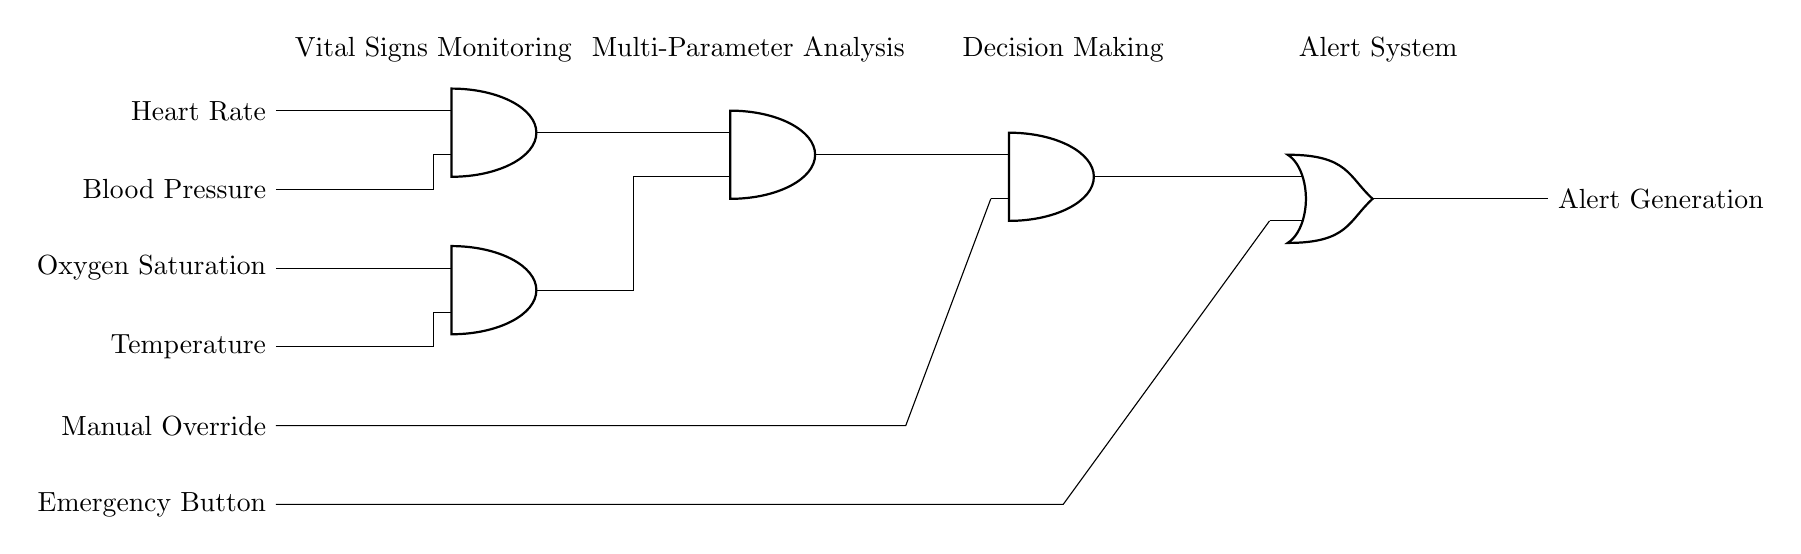What are the input signals for this multi-input logic gate system? The circuit diagram shows four input signals labeled as Heart Rate, Blood Pressure, Oxygen Saturation, and Temperature. They are the parameters being monitored by the system.
Answer: Heart Rate, Blood Pressure, Oxygen Saturation, Temperature How many AND gates are present in the circuit? By examining the circuit, we see that there are four AND gates connected in a manner that allows for multi-parameter analysis of the input signals.
Answer: Four What is the role of the OR gate in this circuit? The OR gate generates alerts based on the output from the AND gates and the Emergency Button. If any of its inputs are activated, the output will signal alert generation.
Answer: Alert Generation What is the output of the last AND gate connected to? The output of the last AND gate is connected to the OR gate, which then leads to the Alert Generation. This indicates that the AND gate outputs combined signals for alert activation.
Answer: OR gate Which input has an override function in the circuit? The input titled Manual Override serves as a direct control input to the last AND gate, allowing manual intervention in the automated process.
Answer: Manual Override How does the circuit handle emergencies? The circuit incorporates an Emergency Button connected to the OR gate. When pressed, the alert generation mechanism is activated, ensuring that emergencies are promptly addressed.
Answer: Emergency Button 